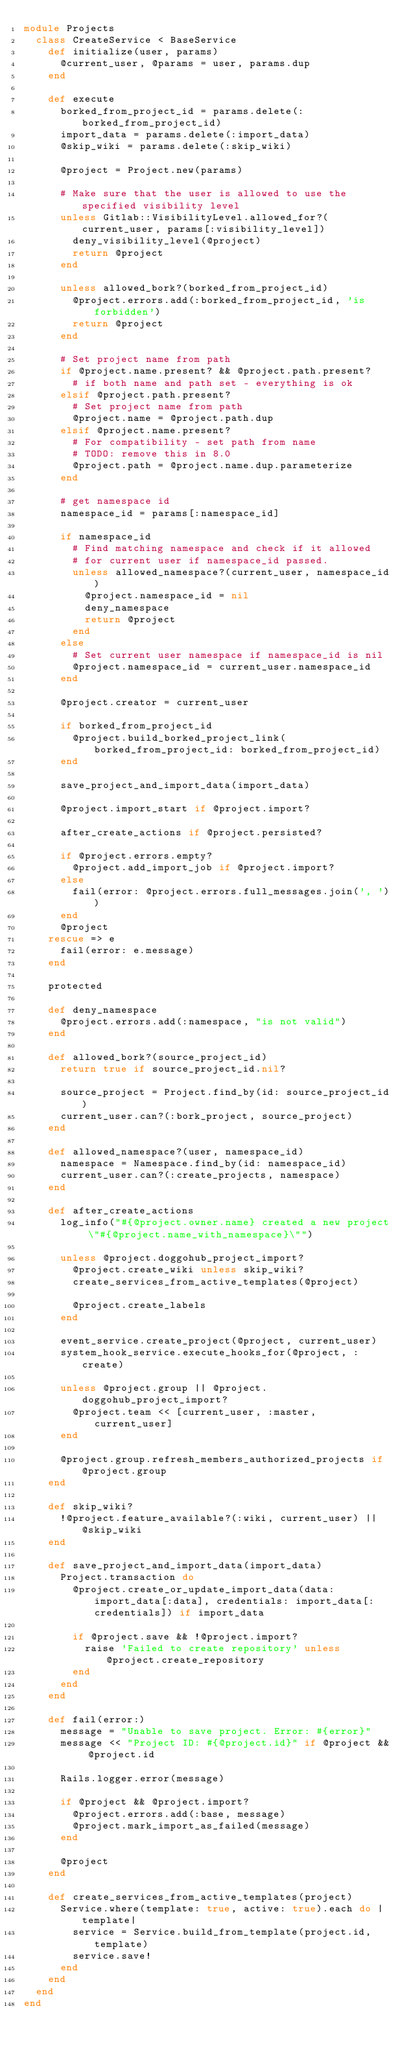Convert code to text. <code><loc_0><loc_0><loc_500><loc_500><_Ruby_>module Projects
  class CreateService < BaseService
    def initialize(user, params)
      @current_user, @params = user, params.dup
    end

    def execute
      borked_from_project_id = params.delete(:borked_from_project_id)
      import_data = params.delete(:import_data)
      @skip_wiki = params.delete(:skip_wiki)

      @project = Project.new(params)

      # Make sure that the user is allowed to use the specified visibility level
      unless Gitlab::VisibilityLevel.allowed_for?(current_user, params[:visibility_level])
        deny_visibility_level(@project)
        return @project
      end

      unless allowed_bork?(borked_from_project_id)
        @project.errors.add(:borked_from_project_id, 'is forbidden')
        return @project
      end

      # Set project name from path
      if @project.name.present? && @project.path.present?
        # if both name and path set - everything is ok
      elsif @project.path.present?
        # Set project name from path
        @project.name = @project.path.dup
      elsif @project.name.present?
        # For compatibility - set path from name
        # TODO: remove this in 8.0
        @project.path = @project.name.dup.parameterize
      end

      # get namespace id
      namespace_id = params[:namespace_id]

      if namespace_id
        # Find matching namespace and check if it allowed
        # for current user if namespace_id passed.
        unless allowed_namespace?(current_user, namespace_id)
          @project.namespace_id = nil
          deny_namespace
          return @project
        end
      else
        # Set current user namespace if namespace_id is nil
        @project.namespace_id = current_user.namespace_id
      end

      @project.creator = current_user

      if borked_from_project_id
        @project.build_borked_project_link(borked_from_project_id: borked_from_project_id)
      end

      save_project_and_import_data(import_data)

      @project.import_start if @project.import?

      after_create_actions if @project.persisted?

      if @project.errors.empty?
        @project.add_import_job if @project.import?
      else
        fail(error: @project.errors.full_messages.join(', '))
      end
      @project
    rescue => e
      fail(error: e.message)
    end

    protected

    def deny_namespace
      @project.errors.add(:namespace, "is not valid")
    end

    def allowed_bork?(source_project_id)
      return true if source_project_id.nil?

      source_project = Project.find_by(id: source_project_id)
      current_user.can?(:bork_project, source_project)
    end

    def allowed_namespace?(user, namespace_id)
      namespace = Namespace.find_by(id: namespace_id)
      current_user.can?(:create_projects, namespace)
    end

    def after_create_actions
      log_info("#{@project.owner.name} created a new project \"#{@project.name_with_namespace}\"")

      unless @project.doggohub_project_import?
        @project.create_wiki unless skip_wiki?
        create_services_from_active_templates(@project)

        @project.create_labels
      end

      event_service.create_project(@project, current_user)
      system_hook_service.execute_hooks_for(@project, :create)

      unless @project.group || @project.doggohub_project_import?
        @project.team << [current_user, :master, current_user]
      end

      @project.group.refresh_members_authorized_projects if @project.group
    end

    def skip_wiki?
      !@project.feature_available?(:wiki, current_user) || @skip_wiki
    end

    def save_project_and_import_data(import_data)
      Project.transaction do
        @project.create_or_update_import_data(data: import_data[:data], credentials: import_data[:credentials]) if import_data

        if @project.save && !@project.import?
          raise 'Failed to create repository' unless @project.create_repository
        end
      end
    end

    def fail(error:)
      message = "Unable to save project. Error: #{error}"
      message << "Project ID: #{@project.id}" if @project && @project.id

      Rails.logger.error(message)

      if @project && @project.import?
        @project.errors.add(:base, message)
        @project.mark_import_as_failed(message)
      end

      @project
    end

    def create_services_from_active_templates(project)
      Service.where(template: true, active: true).each do |template|
        service = Service.build_from_template(project.id, template)
        service.save!
      end
    end
  end
end
</code> 